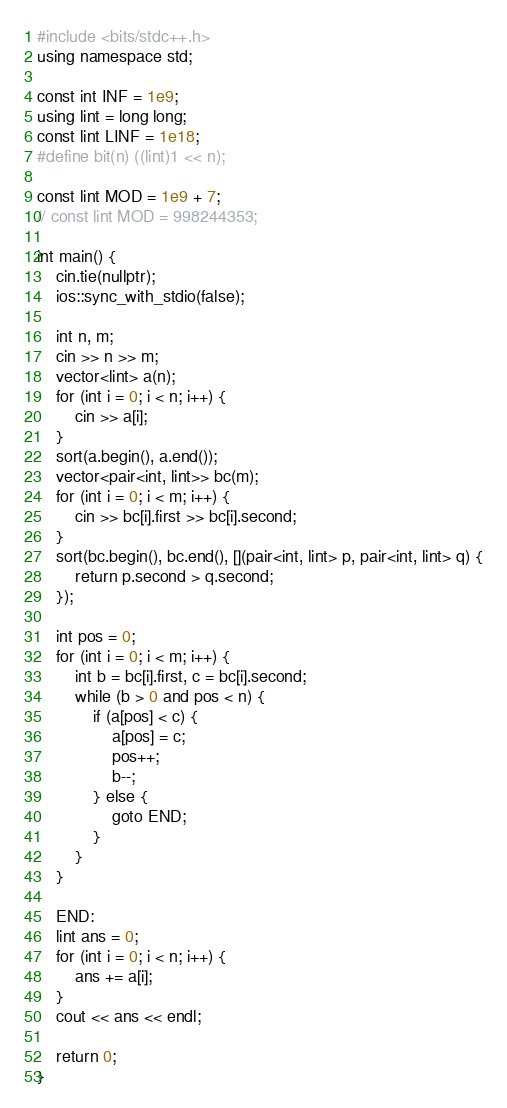Convert code to text. <code><loc_0><loc_0><loc_500><loc_500><_C++_>#include <bits/stdc++.h>
using namespace std;

const int INF = 1e9;
using lint = long long;
const lint LINF = 1e18;
#define bit(n) ((lint)1 << n);

const lint MOD = 1e9 + 7;
// const lint MOD = 998244353;

int main() {
    cin.tie(nullptr);
    ios::sync_with_stdio(false);

    int n, m;
    cin >> n >> m;
    vector<lint> a(n);
    for (int i = 0; i < n; i++) {
        cin >> a[i];
    }
    sort(a.begin(), a.end());
    vector<pair<int, lint>> bc(m);
    for (int i = 0; i < m; i++) {
        cin >> bc[i].first >> bc[i].second;
    }
    sort(bc.begin(), bc.end(), [](pair<int, lint> p, pair<int, lint> q) {
        return p.second > q.second;
    });

    int pos = 0;
    for (int i = 0; i < m; i++) {
        int b = bc[i].first, c = bc[i].second;
        while (b > 0 and pos < n) {
            if (a[pos] < c) {
                a[pos] = c;
                pos++;
                b--;
            } else {
                goto END;
            }
        }
    }

    END:
    lint ans = 0;
    for (int i = 0; i < n; i++) {
        ans += a[i];
    }
    cout << ans << endl;

    return 0;
}</code> 